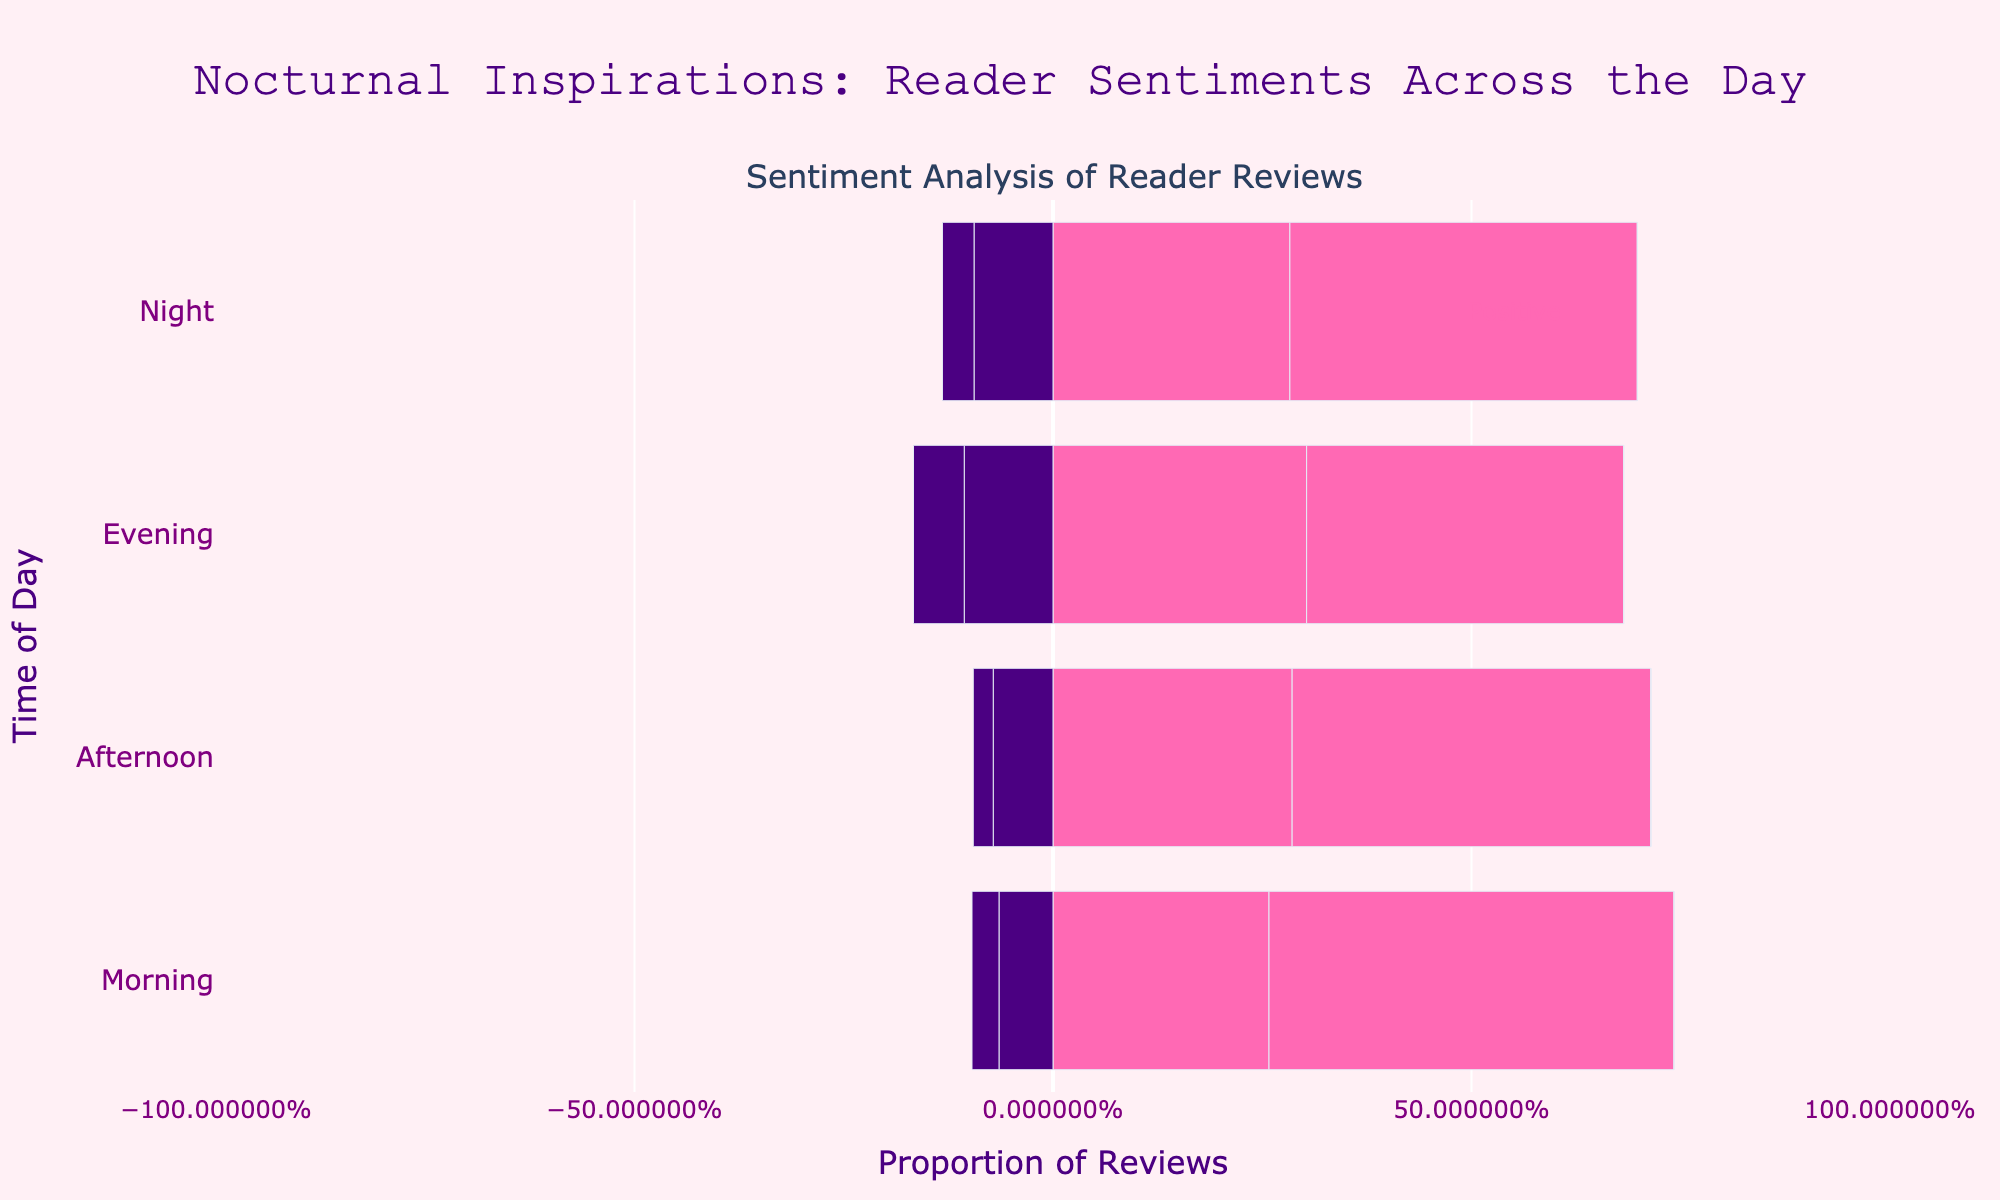How does the proportion of positive reviews in the evening compare to the night? The proportion of positive reviews in the evening is shown by the length of the pink bars extending to the right, which appear longer than those in the night. To compare, observe that the evening has higher positive reviews visually.
Answer: Evening has more positive reviews Which time period has the highest proportion of negative reviews? The proportion of negative reviews is indicated by the length of the bars extending to the left. It appears that evening has the most pronounced negative reviews, as the negative purple bars are the longest in the evening compared to other periods.
Answer: Evening What is the combined proportion of neutral reviews in the morning and afternoon? To find the combined proportion of neutral reviews, add the lengths of the middle purple bars (neutral) for the morning and afternoon. Based on the visualized proportions, morning neutrality is around 17% and afternoon neutrality is around 20%, combining gives approximately 37%.
Answer: Approximately 37% In which time period is the difference between positive and negative reviews the greatest? Compare the visual distances between the longest positive (pink) and negative (purple) bars for each time period. The evening has the largest positive-negative difference since its pink bars are much longer, and its purple bars are also noticeable.
Answer: Evening Which sentiment dominates the night time period? Observe the proportional lengths of the bars: pink (positive), purple (neutral), and purple (negative). Positive reviews dominate as the longest pink bars extend farther right compared to the others.
Answer: Positive How does the proportion of 5-star reviews in the morning compare to the afternoon? Compare the lengths of the pink bars corresponding to the 5-star reviews in the morning and afternoon. The morning's 5-star reviews are proportionally shorter than those in the afternoon.
Answer: Afternoon has a higher proportion Among all time periods, which period shows the smallest proportion of negative reviews? Look at the purple bars extending to the left and find the shortest one. Morning has the shortest negative review bars, indicating the smallest proportion of negative reviews.
Answer: Morning What is the overall trend in sentiment from morning to night? Observe changes in bar lengths across time periods. Positive (pink) reviews increase progressively, reaching the highest at night, whereas negative (purple) reviews are least in the morning and slightly increase but peak in the evening.
Answer: Increasing positive trend, peaking at night For neutral reviews, which period shows the highest review count visually? Check the middle purple bars across all time periods. Visually, the longest middle purple bar corresponds to the evening, indicating the highest neutral review count.
Answer: Evening Is there a time period where neutral and negative reviews combined are more than positive reviews? Compare the combined length of purple bars (neutral + negative) against the length of pink bars (positive) for each period. In the evening, the combined length of neutral and negative reviews approaches but doesn't surpass the length of positive reviews.
Answer: No 